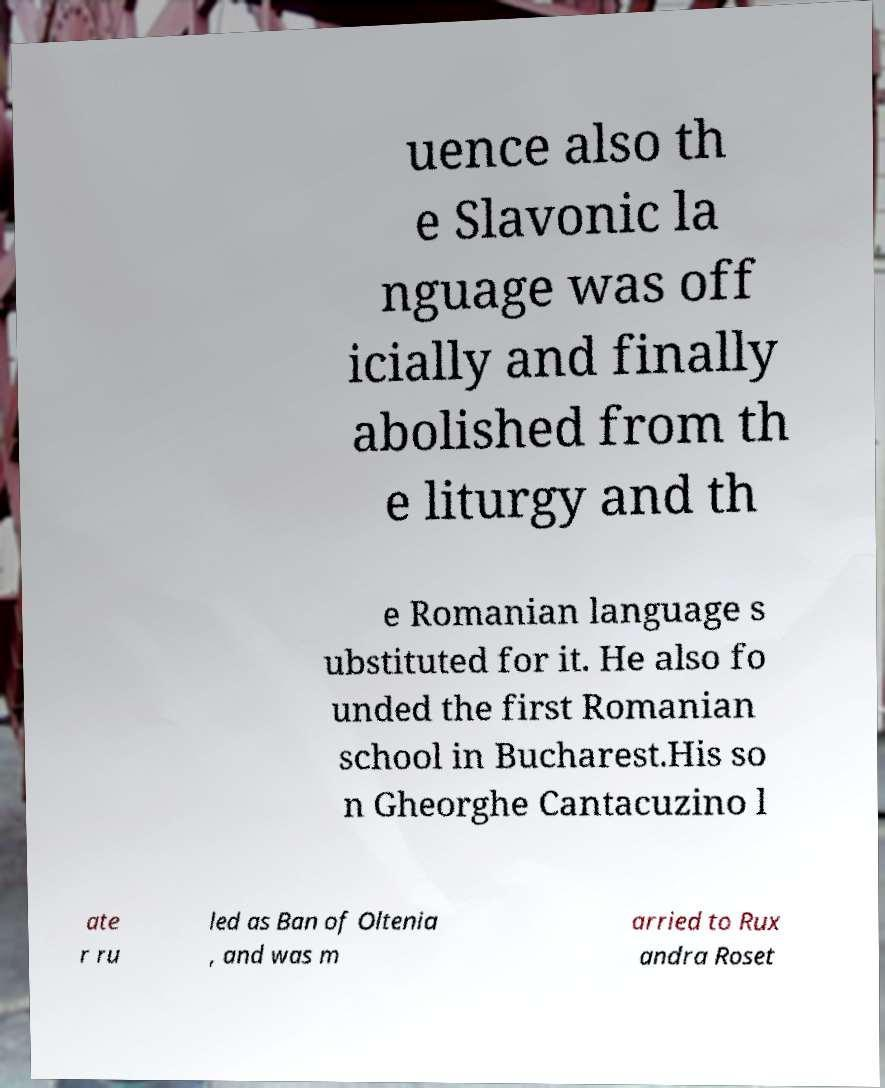What messages or text are displayed in this image? I need them in a readable, typed format. uence also th e Slavonic la nguage was off icially and finally abolished from th e liturgy and th e Romanian language s ubstituted for it. He also fo unded the first Romanian school in Bucharest.His so n Gheorghe Cantacuzino l ate r ru led as Ban of Oltenia , and was m arried to Rux andra Roset 